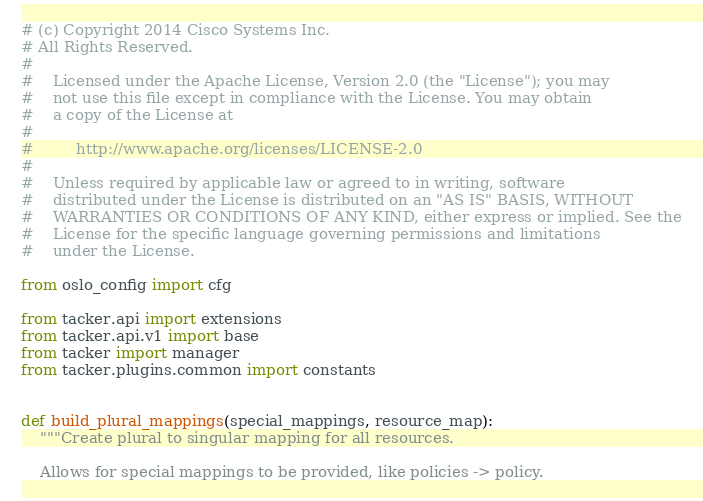Convert code to text. <code><loc_0><loc_0><loc_500><loc_500><_Python_># (c) Copyright 2014 Cisco Systems Inc.
# All Rights Reserved.
#
#    Licensed under the Apache License, Version 2.0 (the "License"); you may
#    not use this file except in compliance with the License. You may obtain
#    a copy of the License at
#
#         http://www.apache.org/licenses/LICENSE-2.0
#
#    Unless required by applicable law or agreed to in writing, software
#    distributed under the License is distributed on an "AS IS" BASIS, WITHOUT
#    WARRANTIES OR CONDITIONS OF ANY KIND, either express or implied. See the
#    License for the specific language governing permissions and limitations
#    under the License.

from oslo_config import cfg

from tacker.api import extensions
from tacker.api.v1 import base
from tacker import manager
from tacker.plugins.common import constants


def build_plural_mappings(special_mappings, resource_map):
    """Create plural to singular mapping for all resources.

    Allows for special mappings to be provided, like policies -> policy.</code> 